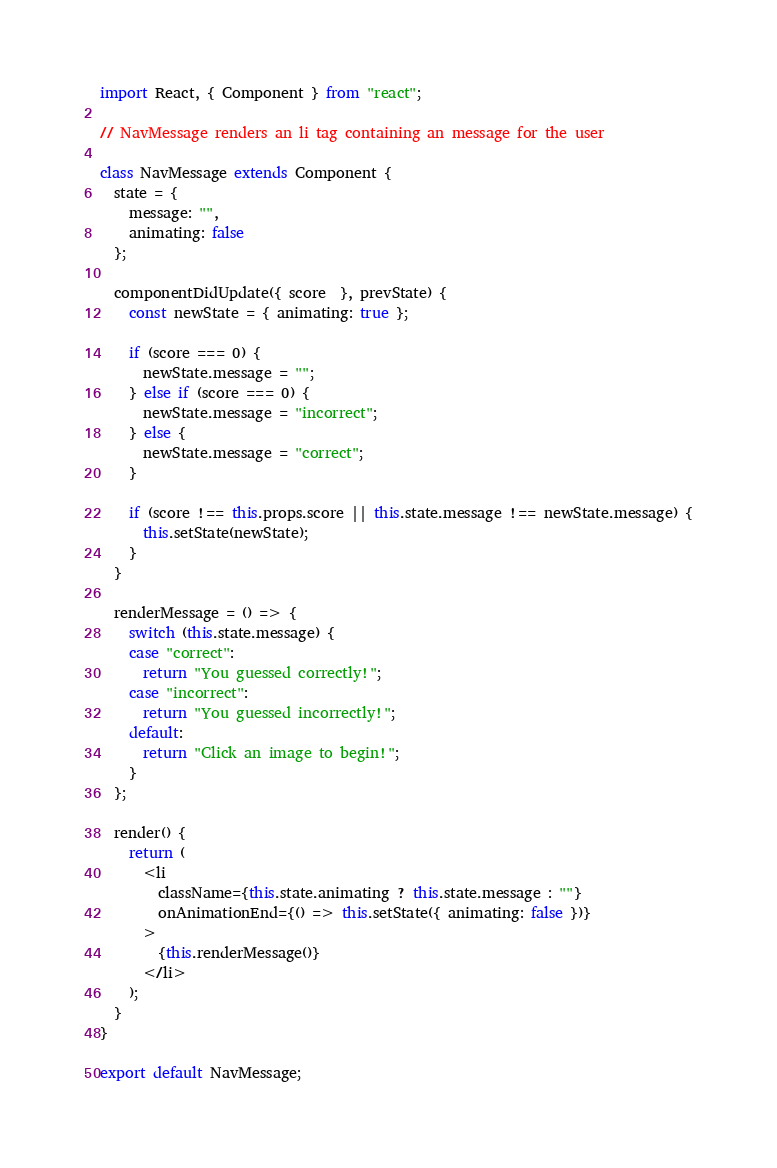<code> <loc_0><loc_0><loc_500><loc_500><_JavaScript_>import React, { Component } from "react";

// NavMessage renders an li tag containing an message for the user

class NavMessage extends Component {
  state = {
    message: "",
    animating: false
  };

  componentDidUpdate({ score  }, prevState) {
    const newState = { animating: true };

    if (score === 0) {
      newState.message = "";
    } else if (score === 0) {
      newState.message = "incorrect";
    } else {
      newState.message = "correct";
    }

    if (score !== this.props.score || this.state.message !== newState.message) {
      this.setState(newState);
    }
  }

  renderMessage = () => {
    switch (this.state.message) {
    case "correct":
      return "You guessed correctly!";
    case "incorrect":
      return "You guessed incorrectly!";
    default:
      return "Click an image to begin!";
    }
  };

  render() {
    return (
      <li
        className={this.state.animating ? this.state.message : ""}
        onAnimationEnd={() => this.setState({ animating: false })}
      >
        {this.renderMessage()}
      </li>
    );
  }
}

export default NavMessage;
</code> 